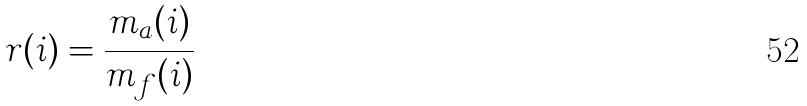Convert formula to latex. <formula><loc_0><loc_0><loc_500><loc_500>r ( i ) = \frac { m _ { a } ( i ) } { m _ { f } ( i ) }</formula> 